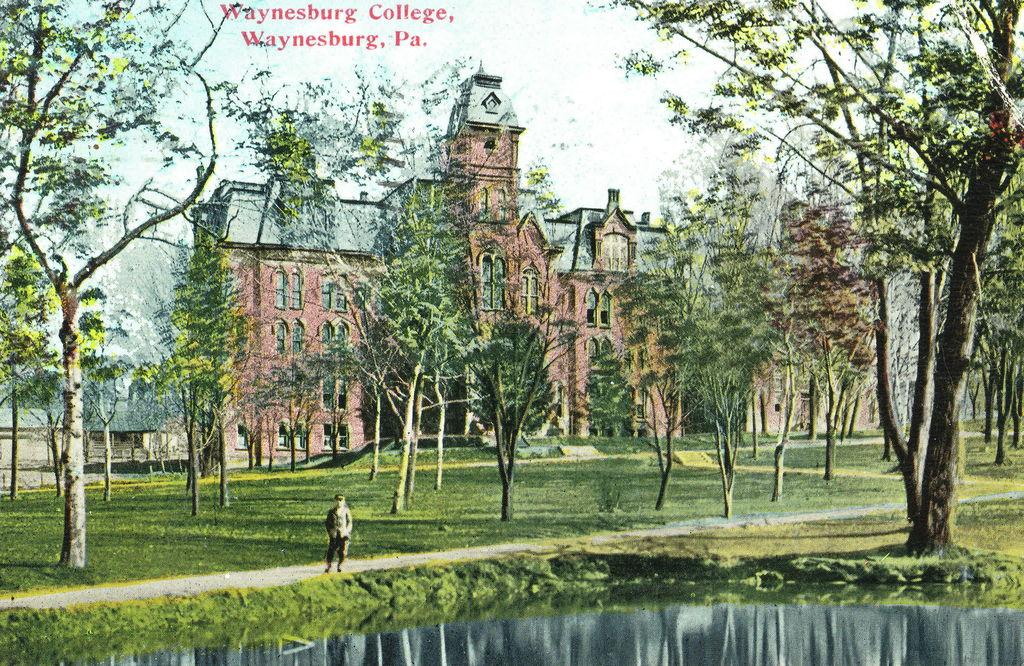What natural element is present in the image? There is water in the image. What type of vegetation can be seen in the image? There is grass in the image. Can you describe the person in the image? There is a person standing in the image. What other natural elements are present in the image? There are trees in the image. What man-made structures can be seen in the image? There are buildings in the image. What is visible in the background of the image? The sky is visible in the image. What shape is the zipper on the bear's outfit in the image? There are no bears or zippers present in the image. 